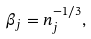<formula> <loc_0><loc_0><loc_500><loc_500>\beta _ { j } = n _ { j } ^ { - 1 / 3 } ,</formula> 